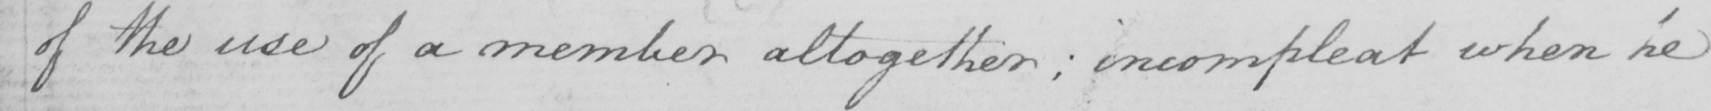Please provide the text content of this handwritten line. of the use of a member altogether: incompleat when he 